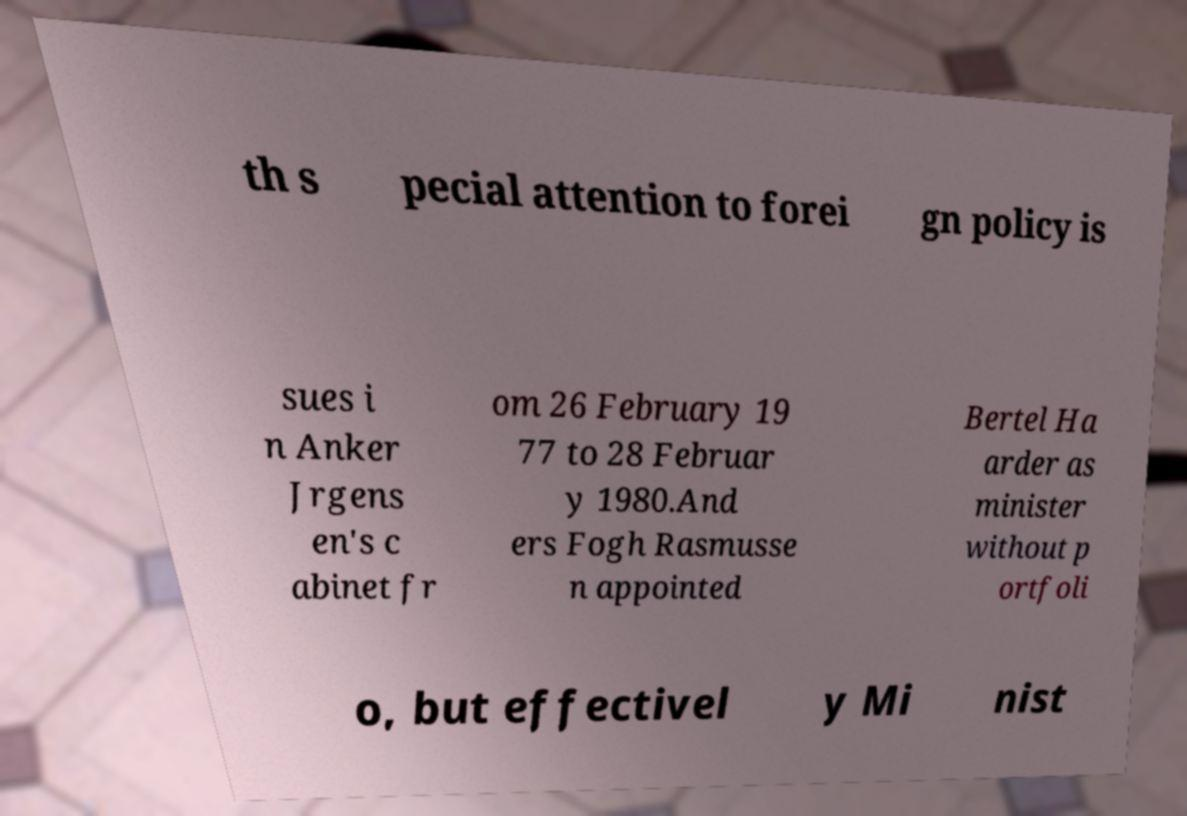Could you extract and type out the text from this image? th s pecial attention to forei gn policy is sues i n Anker Jrgens en's c abinet fr om 26 February 19 77 to 28 Februar y 1980.And ers Fogh Rasmusse n appointed Bertel Ha arder as minister without p ortfoli o, but effectivel y Mi nist 